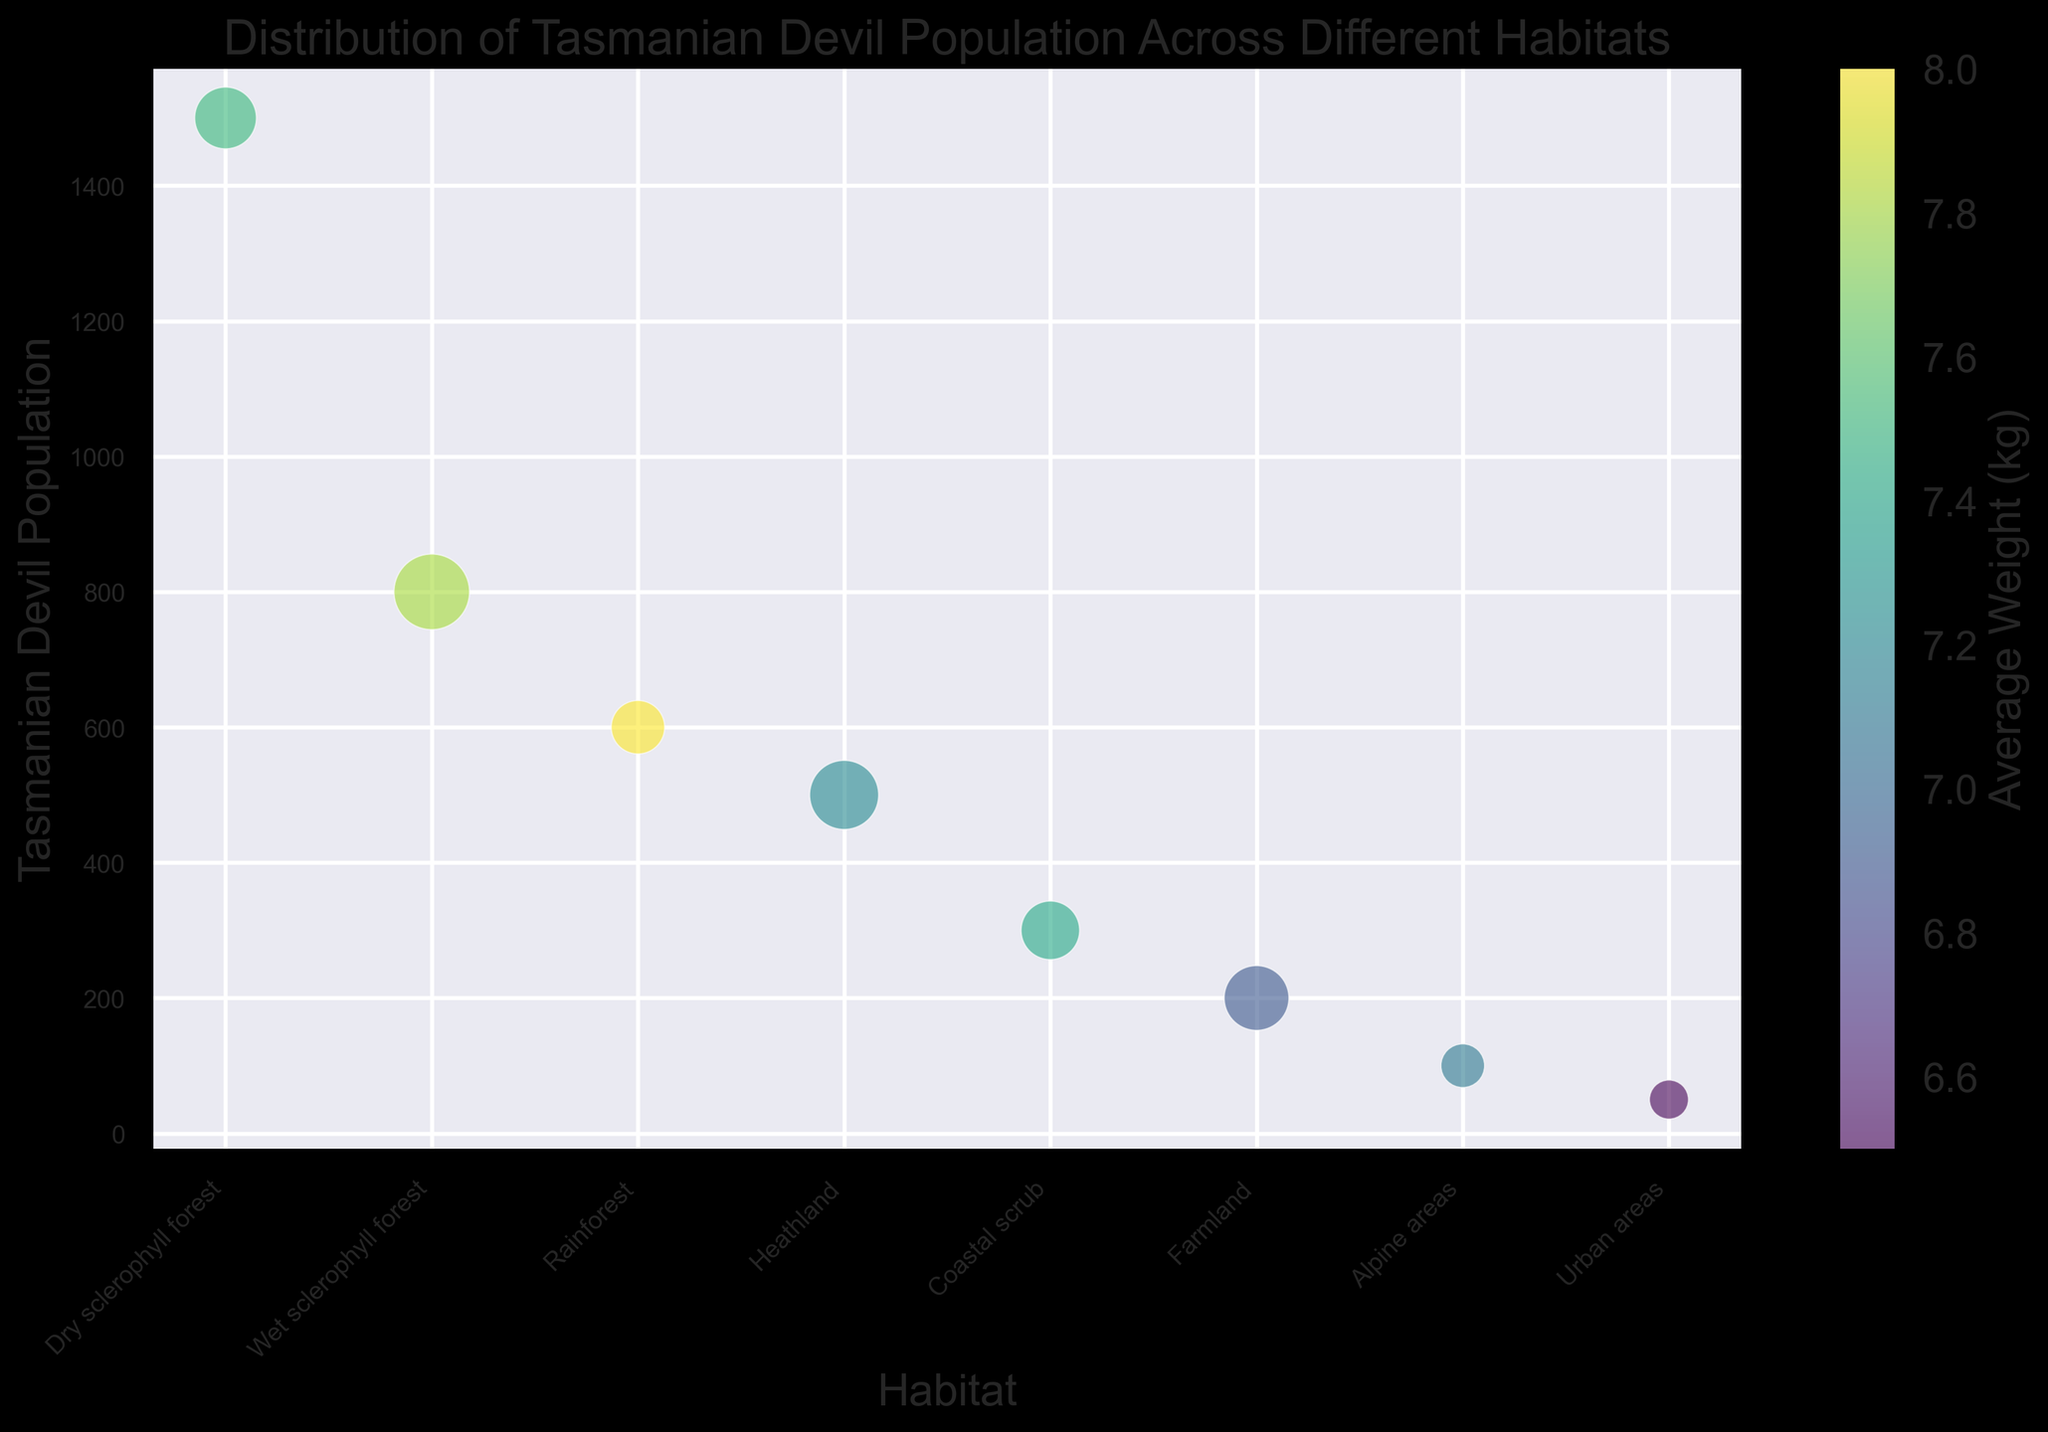Which habitat has the highest Tasmanian devil population? By observing the y-axis values of the bubble chart, the habitat "Dry sclerophyll forest" has the highest population bubble at 1500.
Answer: Dry sclerophyll forest Which habitat has the lowest average weight of Tasmanian devils? The color bar indicates average weight, where lighter colors represent lower weight. The lightest color corresponds to "Urban areas" with a weight of 6.5 kg.
Answer: Urban areas Which habitats have Tasmanian devil populations less than 500? Observing the bubbles below the 500 mark on the y-axis, the habitats are "Coastal scrub," "Farmland," "Alpine areas," and "Urban areas."
Answer: Coastal scrub, Farmland, Alpine areas, Urban areas Which habitat has a similar average weight to the Wet sclerophyll forest but a smaller population? Wet sclerophyll forest has an average weight of 7.8 kg. By comparing the bubble colors, "Rainforest" also has an average weight of 8.0 kg but a smaller population (600).
Answer: Rainforest Which habitat has the second-largest bubble? Bubble sizes are scaled by area, and the second-largest bubble corresponds to the "Wet sclerophyll forest" with an area of 300.
Answer: Wet sclerophyll forest What is the total area covered by habitats with populations above 500? The habitats are "Dry sclerophyll forest," "Wet sclerophyll forest," and "Rainforest" with areas 200, 300, and 150 respectively. The total is 200 + 300 + 150 = 650.
Answer: 650 How does the Tasmanian devil population in Heathland compare to Farmland? Heathland has a population of 500, whereas Farmland has 200. Therefore, Heathland’s population is 300 higher than Farmland’s.
Answer: Heathland has 300 more Which habitats have a population density (population/area) greater than 4? Calculate the population density for each: 
Dry sclerophyll forest (1500/200 = 7.5) 
Wet sclerophyll forest (800/300 = 2.67) 
Rainforest (600/150 = 4.0) 
Heathland (500/250 = 2.0) 
Coastal scrub (300/180 = 1.67) 
Farmland (200/220 = 0.91) 
Alpine areas (100/100 = 1.0) 
Urban areas (50/80 = 0.63). 
Only "Dry sclerophyll forest" and "Rainforest" have densities greater than 4.
Answer: Dry sclerophyll forest, Rainforest 